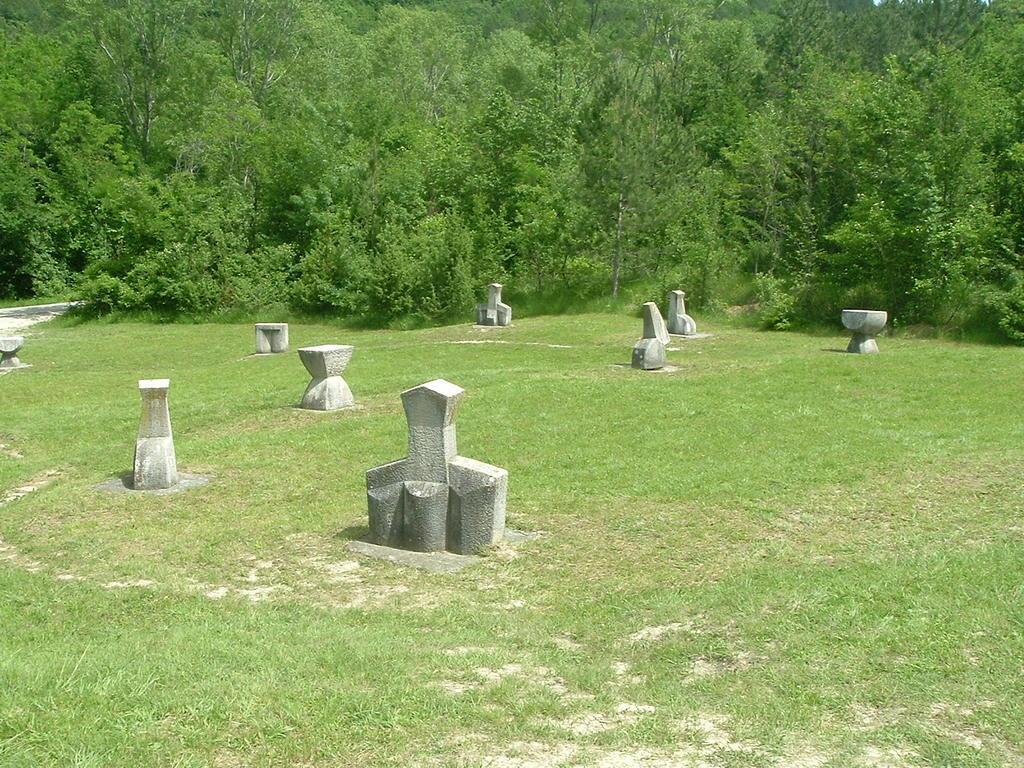Describe this image in one or two sentences. In this image there are some cemeteries, at the bottom there is grass and in the background there are some trees. 